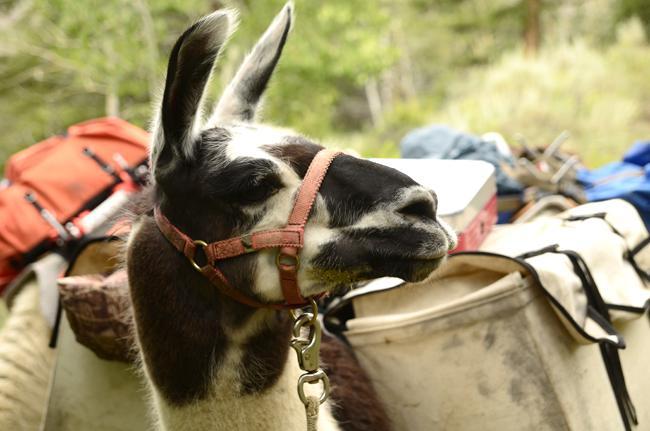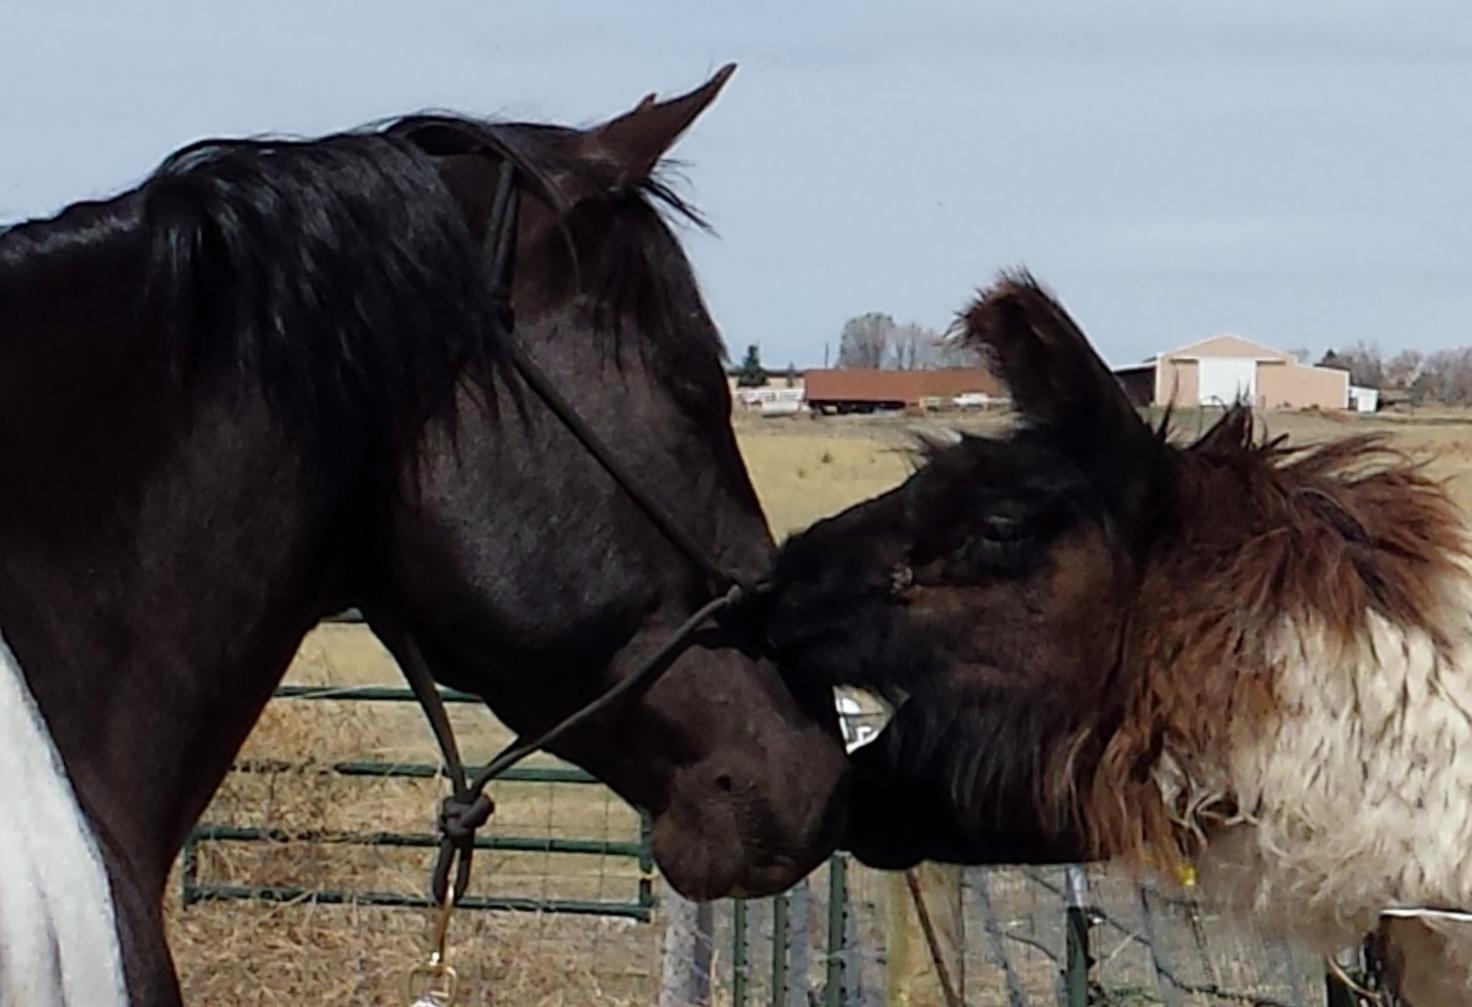The first image is the image on the left, the second image is the image on the right. Given the left and right images, does the statement "In at least one image there is a single baby alpaca with its body facing forward." hold true? Answer yes or no. No. The first image is the image on the left, the second image is the image on the right. Given the left and right images, does the statement "The left image shows a man in shorts and sunglasses standing by a white llama wearing a pack, and the right image shows a forward-turned llama wearing some type of attire." hold true? Answer yes or no. No. 